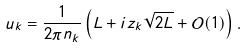Convert formula to latex. <formula><loc_0><loc_0><loc_500><loc_500>u _ { k } = \frac { 1 } { 2 \pi n _ { k } } \left ( L + i z _ { k } \sqrt { 2 L } + \mathcal { O } ( 1 ) \right ) .</formula> 